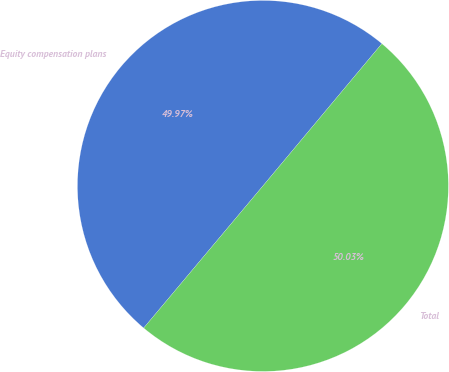Convert chart to OTSL. <chart><loc_0><loc_0><loc_500><loc_500><pie_chart><fcel>Equity compensation plans<fcel>Total<nl><fcel>49.97%<fcel>50.03%<nl></chart> 